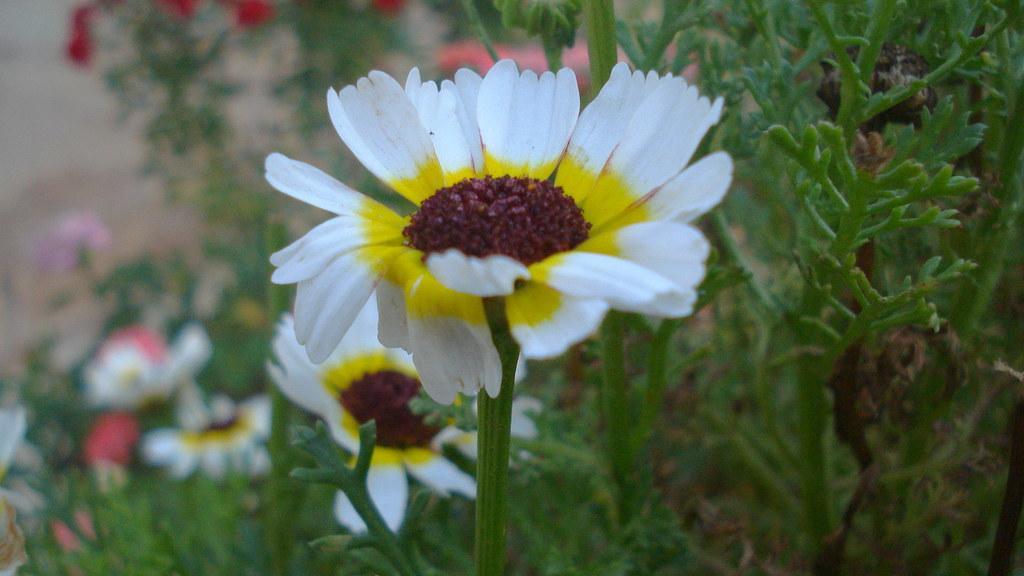In one or two sentences, can you explain what this image depicts? In the foreground of the picture there is a flower. In the background there are flowers and plants. 